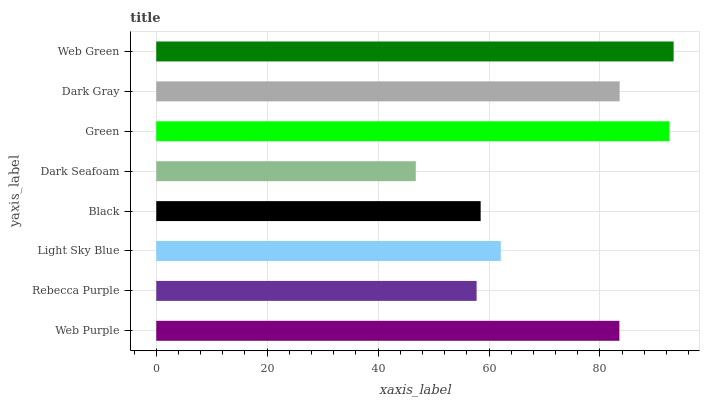Is Dark Seafoam the minimum?
Answer yes or no. Yes. Is Web Green the maximum?
Answer yes or no. Yes. Is Rebecca Purple the minimum?
Answer yes or no. No. Is Rebecca Purple the maximum?
Answer yes or no. No. Is Web Purple greater than Rebecca Purple?
Answer yes or no. Yes. Is Rebecca Purple less than Web Purple?
Answer yes or no. Yes. Is Rebecca Purple greater than Web Purple?
Answer yes or no. No. Is Web Purple less than Rebecca Purple?
Answer yes or no. No. Is Web Purple the high median?
Answer yes or no. Yes. Is Light Sky Blue the low median?
Answer yes or no. Yes. Is Light Sky Blue the high median?
Answer yes or no. No. Is Web Purple the low median?
Answer yes or no. No. 